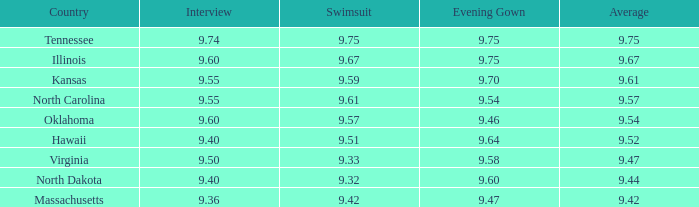Which nation had the swimsuit rating of Illinois. 